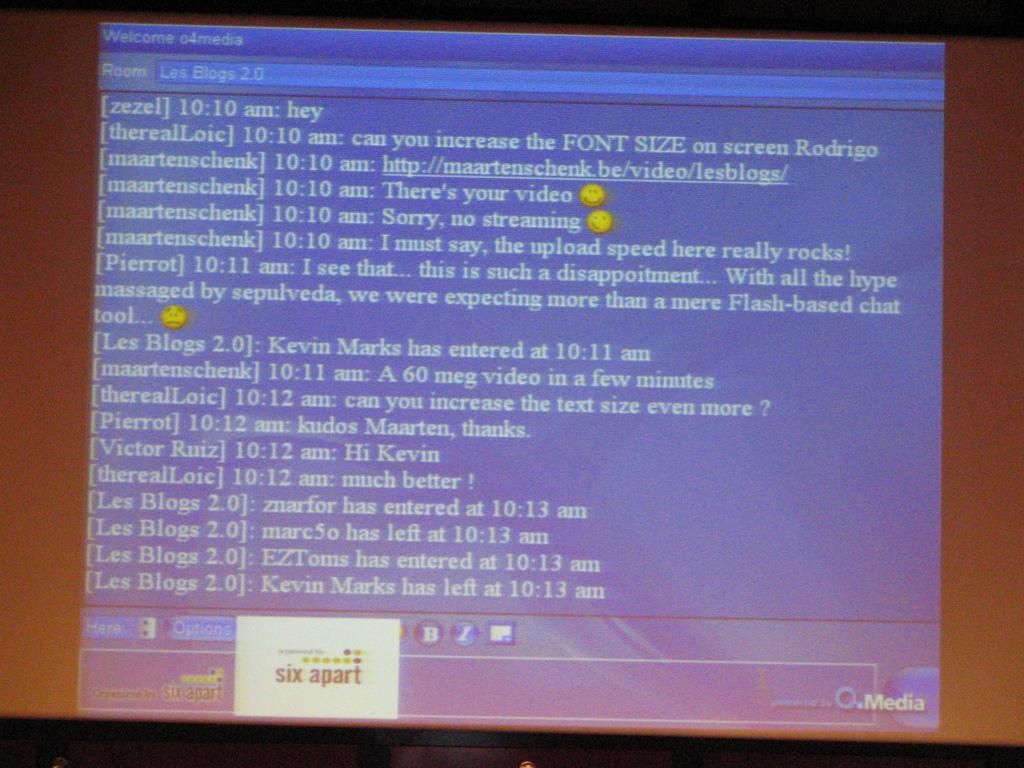<image>
Provide a brief description of the given image. A computer screen showing a chat room for Les Blogs 2.0 